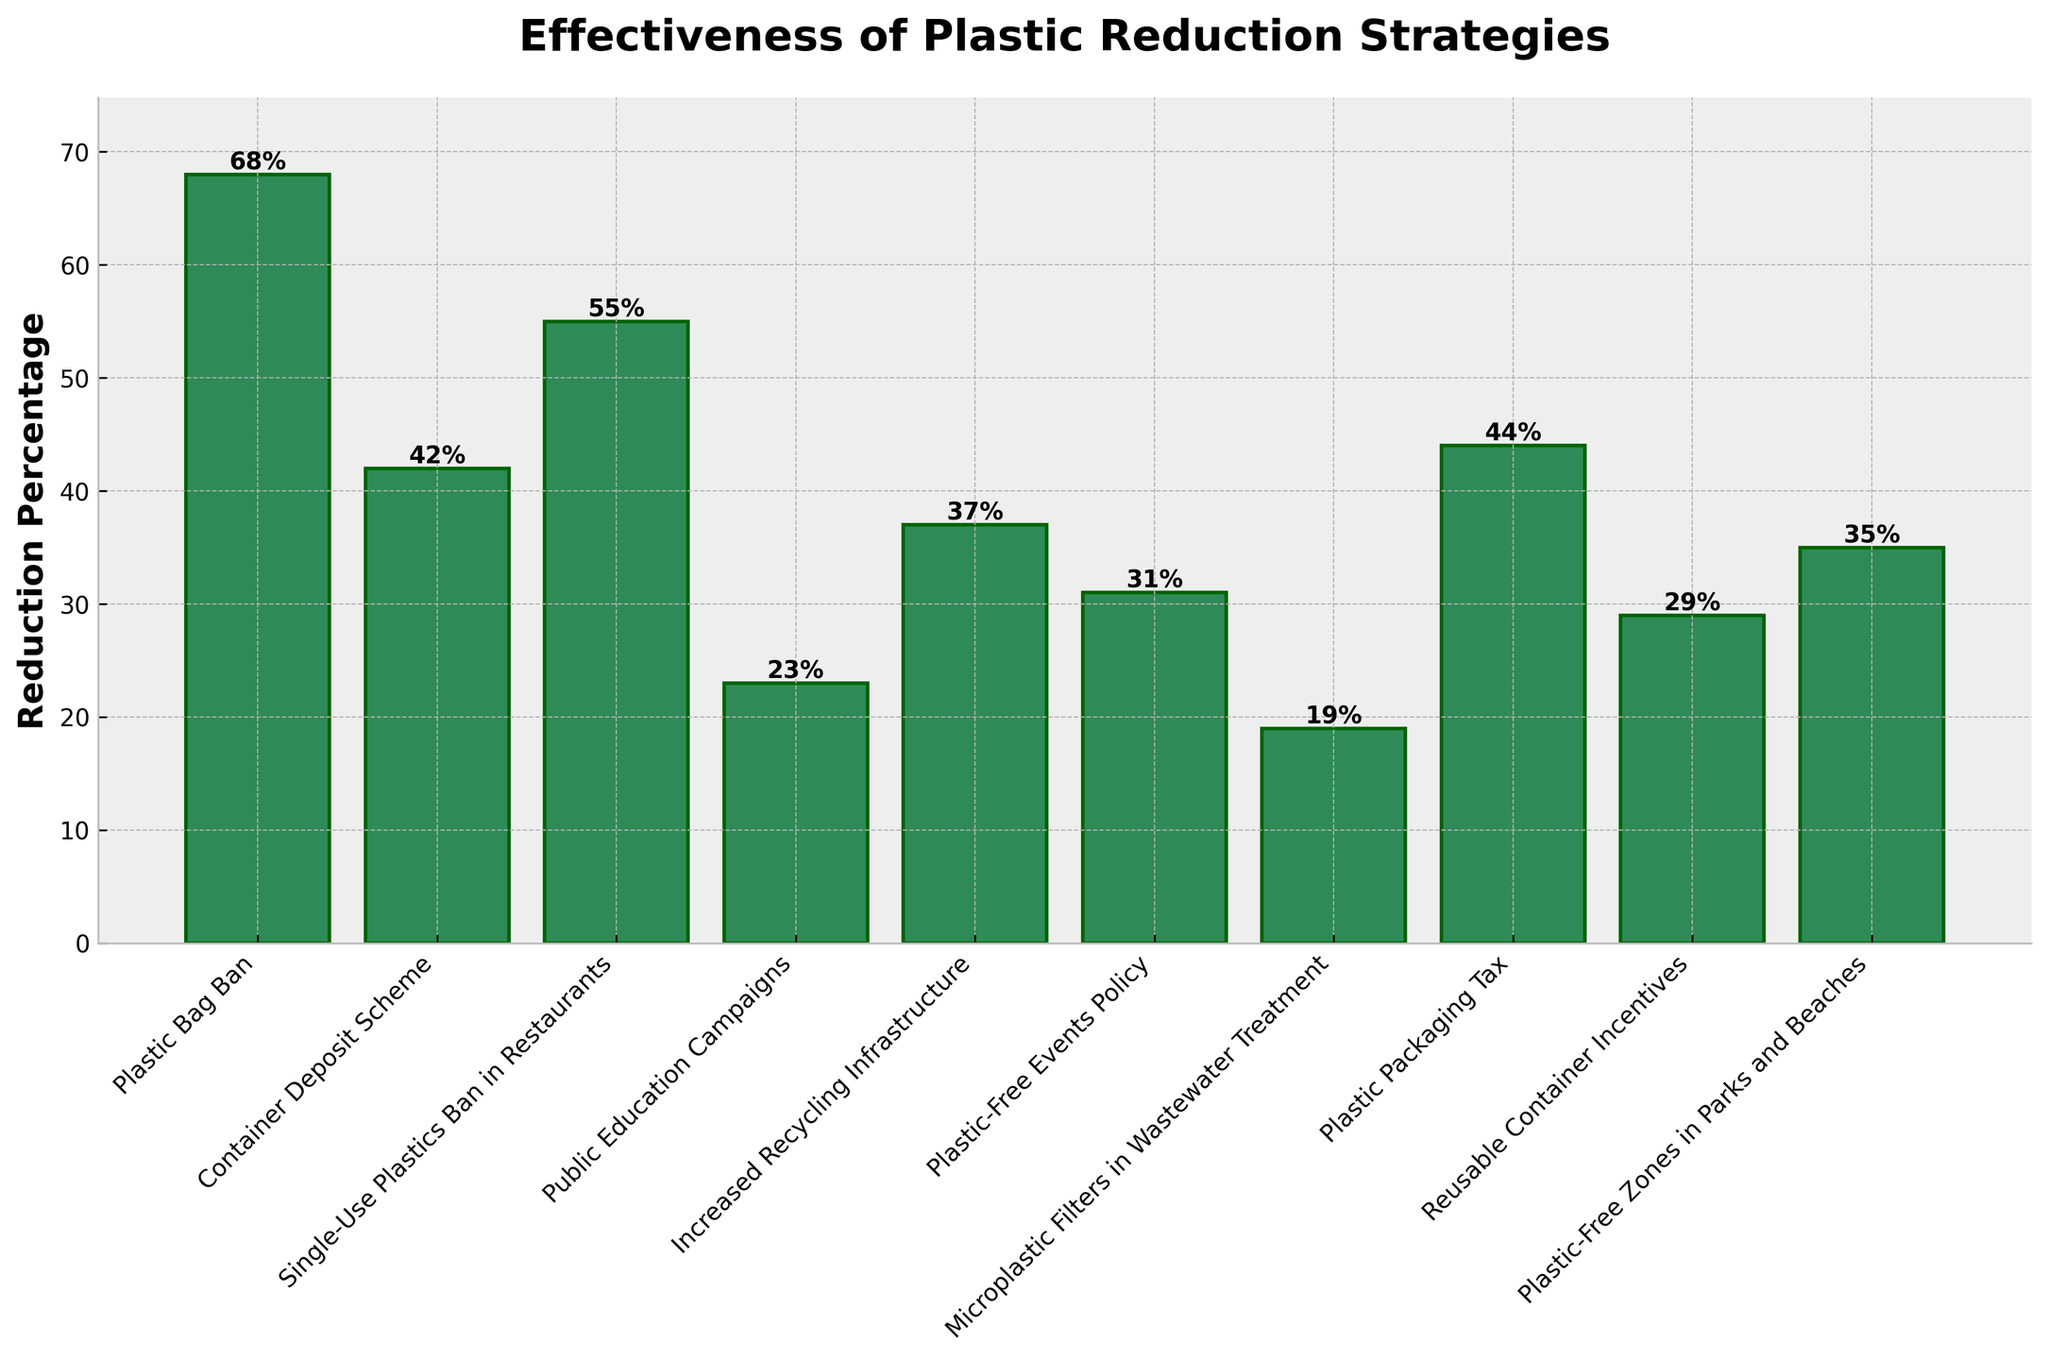Which strategy has the highest reduction percentage? By looking at the height of the bars, the "Plastic Bag Ban" bar is the tallest, indicating it has the highest reduction percentage.
Answer: Plastic Bag Ban What's the difference in reduction percentage between the "Single-Use Plastics Ban in Restaurants" and "Reusable Container Incentives"? The reduction percentage for "Single-Use Plastics Ban in Restaurants" is 55% and for "Reusable Container Incentives" is 29%. The difference is 55% - 29% = 26%.
Answer: 26% Which strategy is more effective, "Public Education Campaigns" or "Plastic-Free Zones in Parks and Beaches"? By comparing the height of the bars, "Plastic-Free Zones in Parks and Beaches" has a reduction percentage of 35%, which is higher than "Public Education Campaigns" at 23%.
Answer: Plastic-Free Zones in Parks and Beaches What is the average reduction percentage of all the strategies combined? Sum up all the reduction percentages: (68 + 42 + 55 + 23 + 37 + 31 + 19 + 44 + 29 + 35) = 383. Then divide by the number of strategies, which is 10. So, the average is 383 / 10 = 38.3%.
Answer: 38.3% Are there any strategies with a reduction percentage below 20%? By looking at the bars, "Microplastic Filters in Wastewater Treatment" has a reduction percentage of 19%, which is below 20%.
Answer: Yes Which strategies have a reduction percentage greater than 50%? By looking at the heights of the bars, "Plastic Bag Ban" (68%) and "Single-Use Plastics Ban in Restaurants" (55%) both have reduction percentages greater than 50%.
Answer: Plastic Bag Ban, Single-Use Plastics Ban in Restaurants How much more effective is the "Plastic Packaging Tax" than "Increased Recycling Infrastructure"? The reduction percentage for "Plastic Packaging Tax" is 44% and for "Increased Recycling Infrastructure" it is 37%. The difference is 44% - 37% = 7%.
Answer: 7% Which two strategies have the closest reduction percentages? By closely inspecting the heights of adjacent bars, "Plastic-Free Zones in Parks and Beaches" (35%) and "Increased Recycling Infrastructure" (37%) have the closest reduction percentages with a difference of 2%.
Answer: Plastic-Free Zones in Parks and Beaches, Increased Recycling Infrastructure 